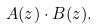Convert formula to latex. <formula><loc_0><loc_0><loc_500><loc_500>A ( z ) \cdot B ( z ) .</formula> 